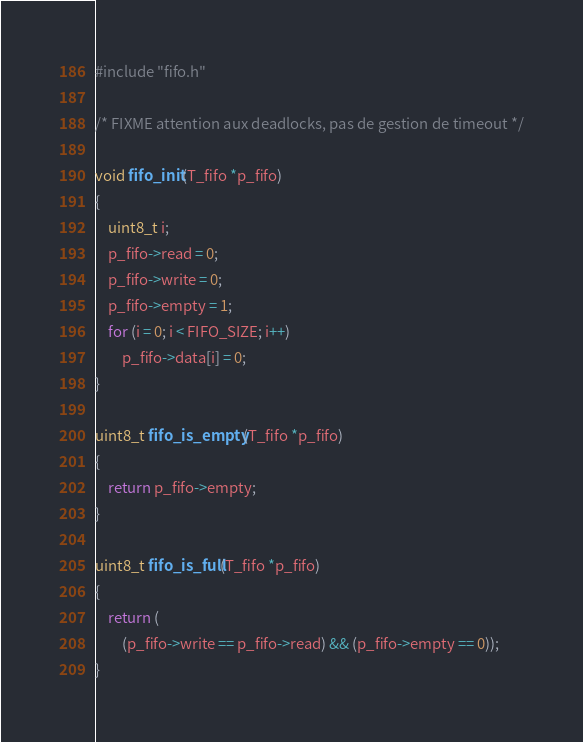<code> <loc_0><loc_0><loc_500><loc_500><_C_>#include "fifo.h"

/* FIXME attention aux deadlocks, pas de gestion de timeout */

void fifo_init(T_fifo *p_fifo)
{
    uint8_t i;
    p_fifo->read = 0;
    p_fifo->write = 0;
    p_fifo->empty = 1;
    for (i = 0; i < FIFO_SIZE; i++)
        p_fifo->data[i] = 0;
}

uint8_t fifo_is_empty(T_fifo *p_fifo)
{
    return p_fifo->empty;
}

uint8_t fifo_is_full(T_fifo *p_fifo)
{
    return (
        (p_fifo->write == p_fifo->read) && (p_fifo->empty == 0));
}
</code> 